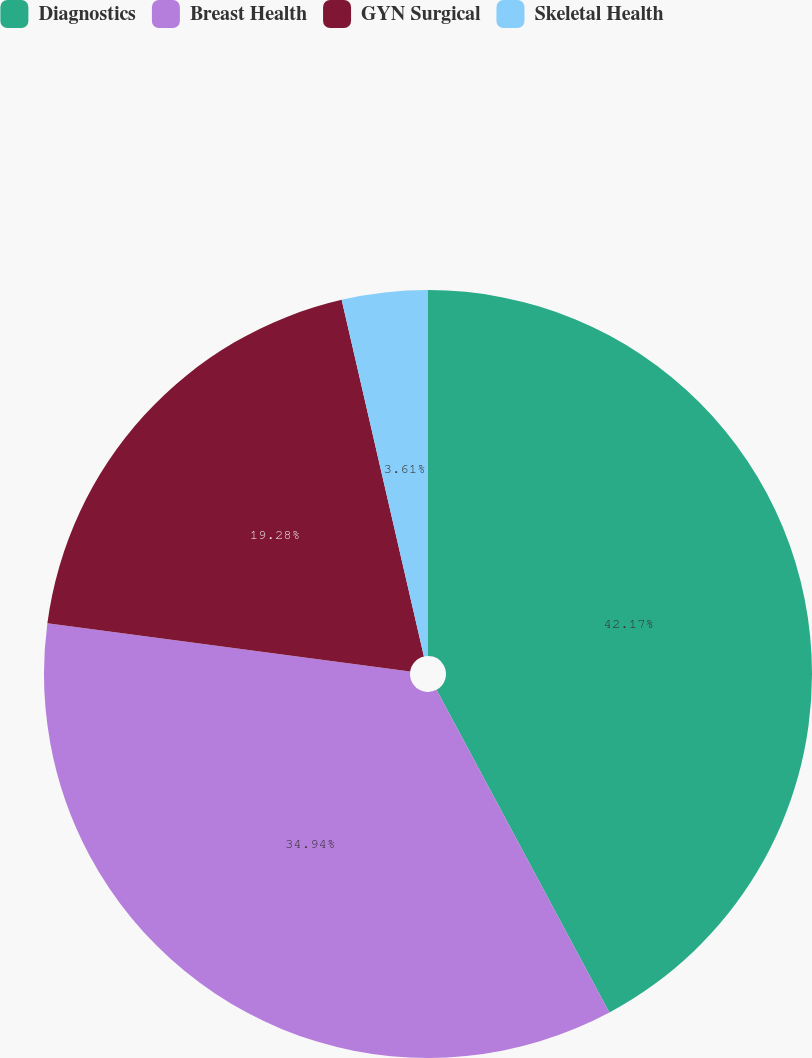Convert chart. <chart><loc_0><loc_0><loc_500><loc_500><pie_chart><fcel>Diagnostics<fcel>Breast Health<fcel>GYN Surgical<fcel>Skeletal Health<nl><fcel>42.17%<fcel>34.94%<fcel>19.28%<fcel>3.61%<nl></chart> 